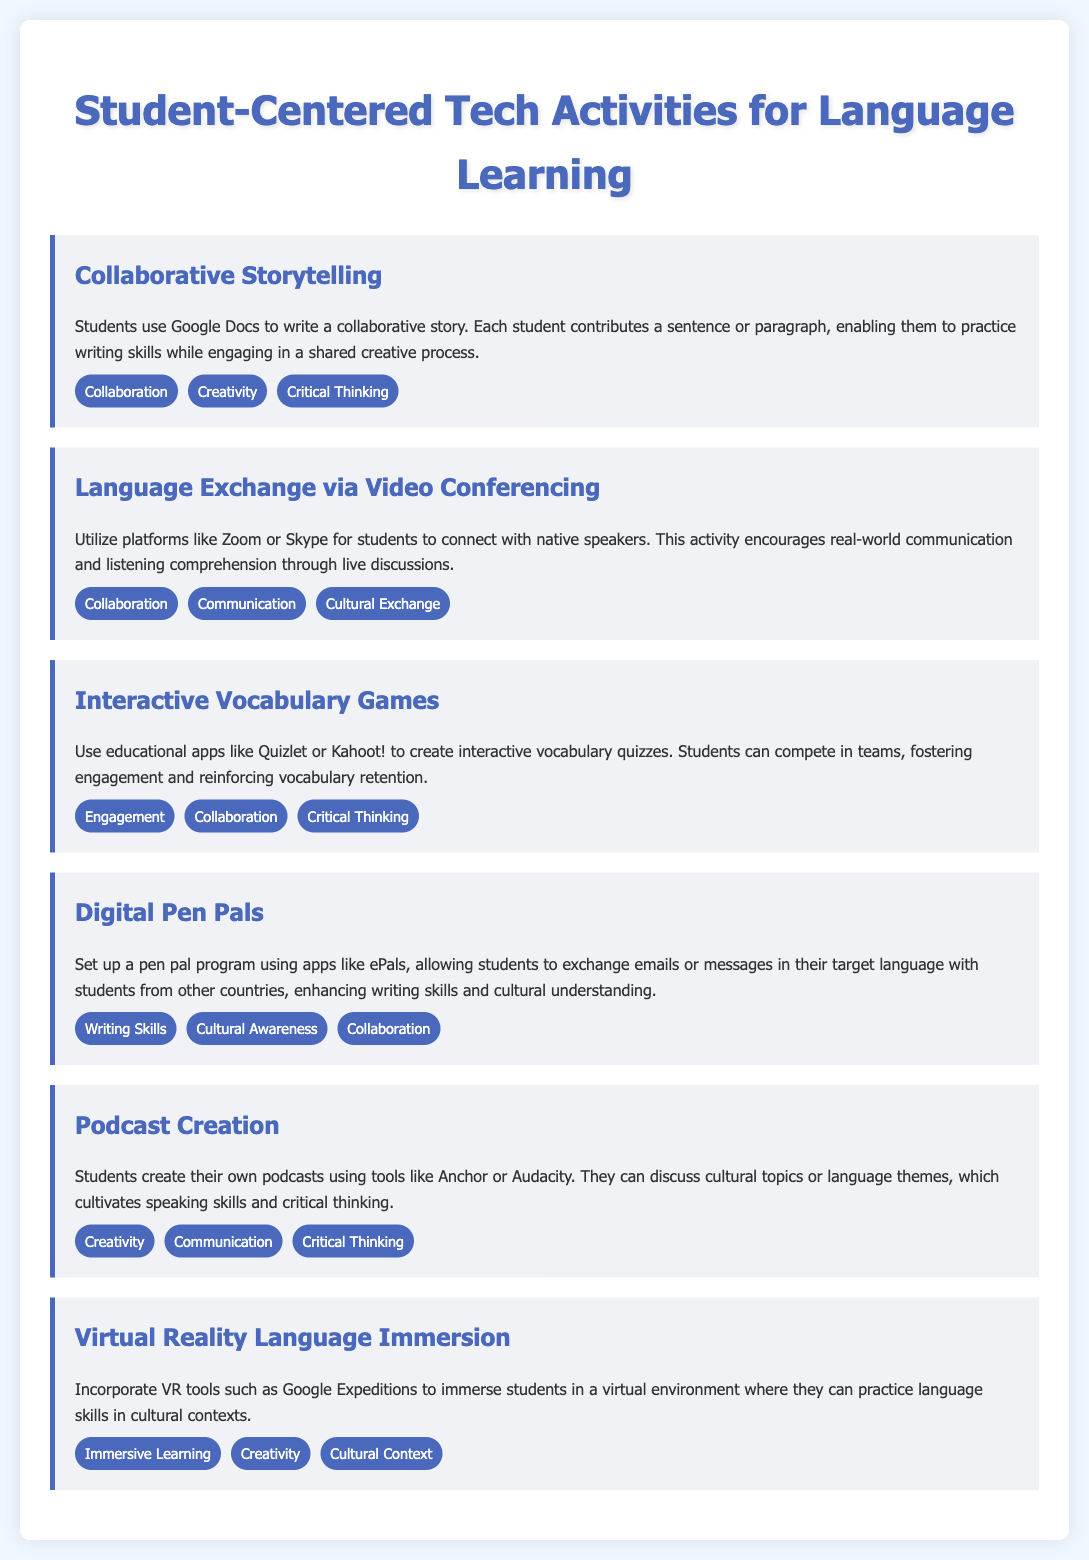What is the first activity listed? The first activity in the document is the one labeled "Collaborative Storytelling."
Answer: Collaborative Storytelling How many focus areas are listed for the "Language Exchange via Video Conferencing"? The document states three focus areas for this activity, which are listed under it.
Answer: Three Which tool is recommended for creating podcasts? The document mentions specific tools for podcast creation, with one being highlighted prominently.
Answer: Anchor What activity encourages the exchange of messages in a target language? The activity that facilitates this type of communication is named in the document.
Answer: Digital Pen Pals Which focus area is common to both "Interactive Vocabulary Games" and "Collaborative Storytelling"? By examining both activities, one can identify shared focus areas mentioned in the document.
Answer: Collaboration How does "Virtual Reality Language Immersion" enhance language skills? The document explains that it provides a type of learning experience that contributes to language acquisition.
Answer: Immersive Learning What is the primary communication aspect promoted by the "Podcast Creation" activity? The document outlines key focuses for this activity, emphasizing its communication benefits.
Answer: Communication How many activities are described in total? The document presents a specific number of student-centered tech activities.
Answer: Six 